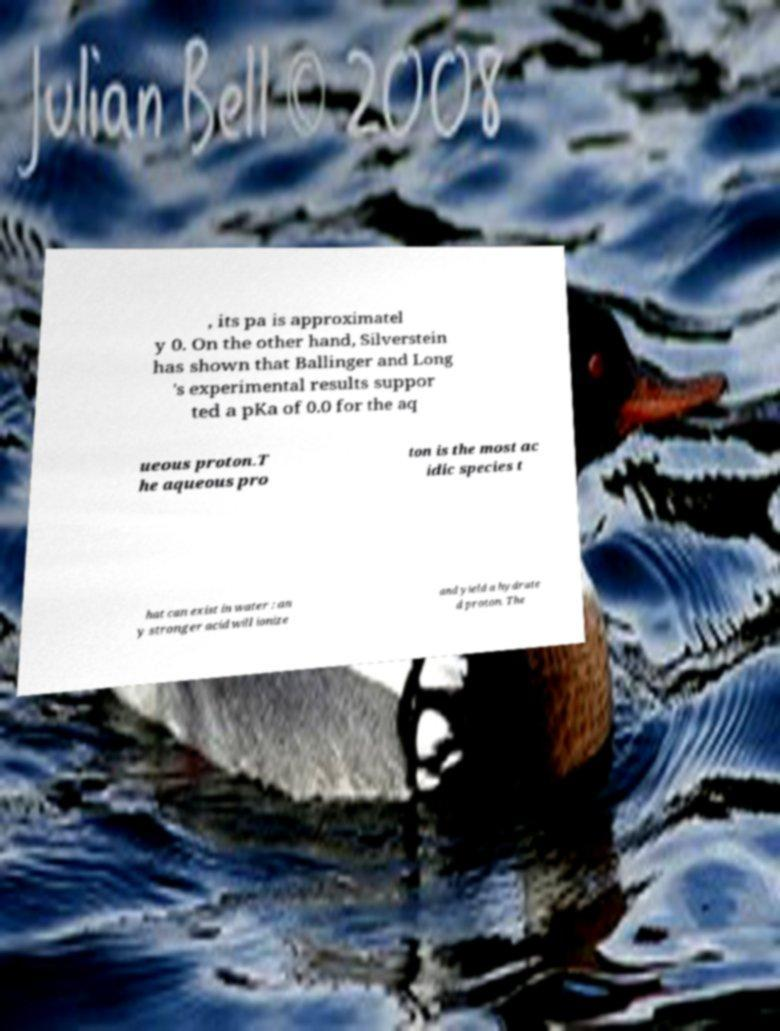Please identify and transcribe the text found in this image. , its pa is approximatel y 0. On the other hand, Silverstein has shown that Ballinger and Long 's experimental results suppor ted a pKa of 0.0 for the aq ueous proton.T he aqueous pro ton is the most ac idic species t hat can exist in water : an y stronger acid will ionize and yield a hydrate d proton. The 